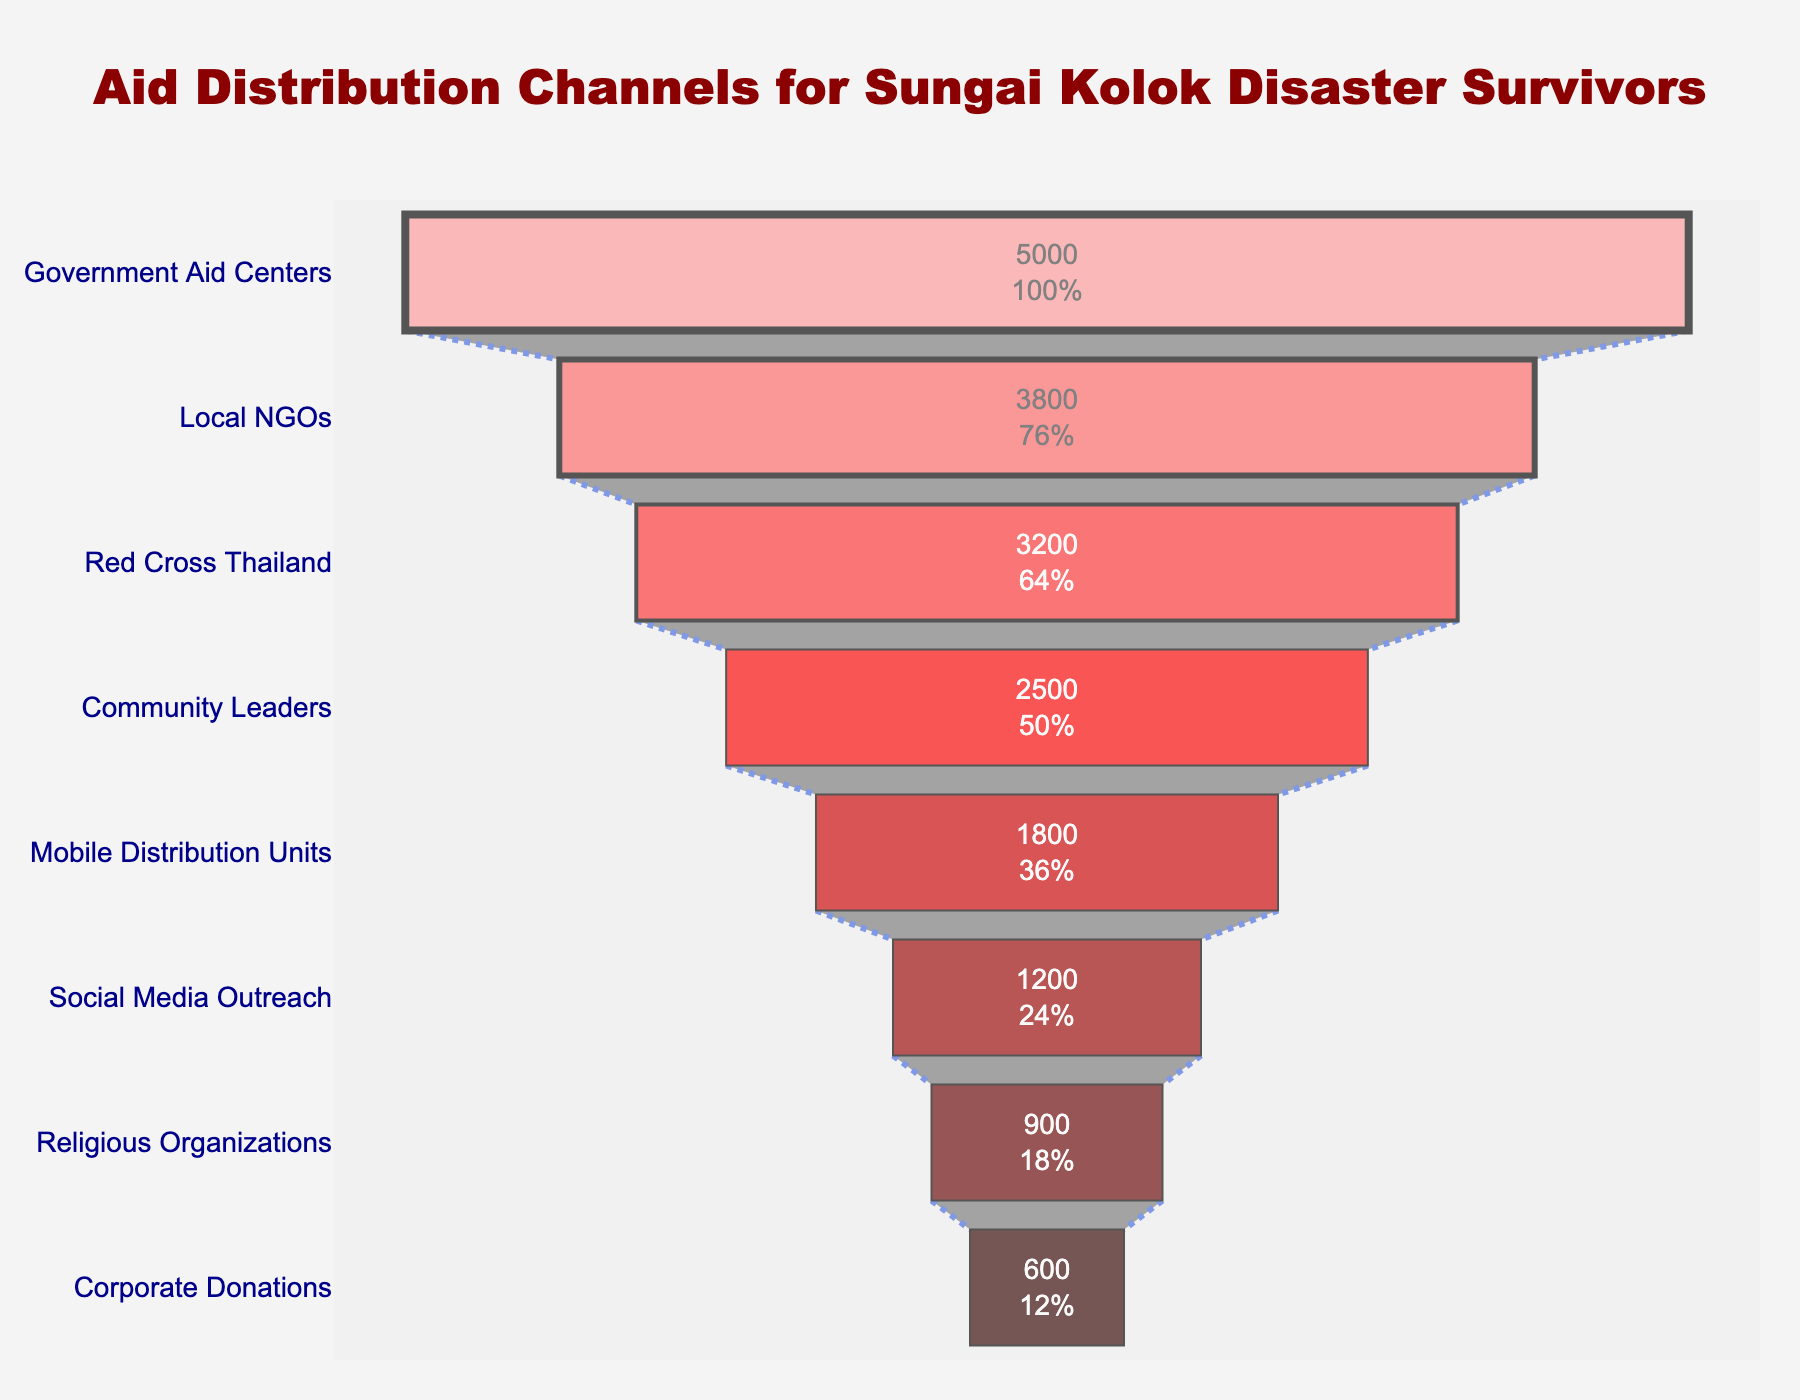How many recipients received aid from Local NGOs? Check the funnel chart and find the value associated with the Local NGOs segment.
Answer: 3800 What percentage of the initial recipients received aid from Mobile Distribution Units? The initial number of recipients is 5000 (Government Aid Centers). The Mobile Distribution Units served 1800. Percentage = (1800 / 5000) * 100.
Answer: 36% Which channel provided aid to the fewest number of recipients? Look at the smallest segment in the funnel chart.
Answer: Corporate Donations How many more recipients were there for Government Aid Centers compared to Corporate Donations? Find the values for Government Aid Centers (5000) and Corporate Donations (600), then calculate the difference. 5000 - 600 = 4400.
Answer: 4400 Which aid channel served fewer recipients than Red Cross Thailand but more than Mobile Distribution Units? Red Cross Thailand has 3200 recipients and Mobile Distribution Units have 1800. The channel between these values is Community Leaders with 2500 recipients.
Answer: Community Leaders What is the total number of recipients served by all channels combined? Sum all the number of recipients for each channel: 5000 + 3800 + 3200 + 2500 + 1800 + 1200 + 900 + 600 = 19000.
Answer: 19000 What's the largest percentage drop between two consecutive aid channels in the funnel chart? Calculate the percentage drop between consecutive channels. For example, between Government Aid Centers (5000) and Local NGOs (3800): ((5000 - 3800) / 5000) * 100 = 24%. Then find the largest drop.
Answer: 24% What is the ratio of recipients between Red Cross Thailand and Religious Organizations? Find the values for Red Cross Thailand (3200) and Religious Organizations (900), then compute the ratio 3200 / 900.
Answer: 3.56 Which segment shows aid distribution through Social Media Outreach? Identify the segment labeled "Social Media Outreach" on the funnel chart and check its position.
Answer: The second smallest segment How many distribution channels are represented in the funnel chart? Count the distinct segments present on the chart.
Answer: 8 